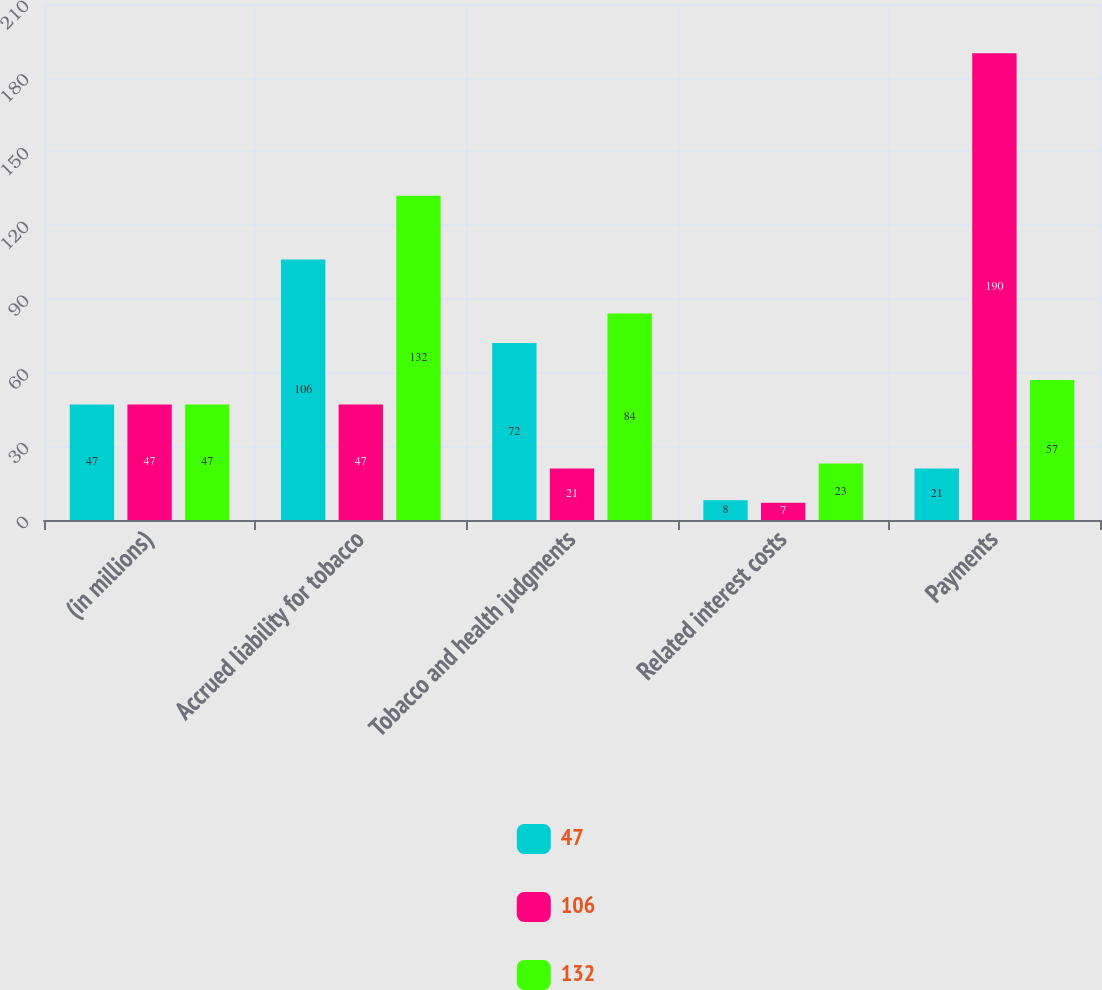<chart> <loc_0><loc_0><loc_500><loc_500><stacked_bar_chart><ecel><fcel>(in millions)<fcel>Accrued liability for tobacco<fcel>Tobacco and health judgments<fcel>Related interest costs<fcel>Payments<nl><fcel>47<fcel>47<fcel>106<fcel>72<fcel>8<fcel>21<nl><fcel>106<fcel>47<fcel>47<fcel>21<fcel>7<fcel>190<nl><fcel>132<fcel>47<fcel>132<fcel>84<fcel>23<fcel>57<nl></chart> 